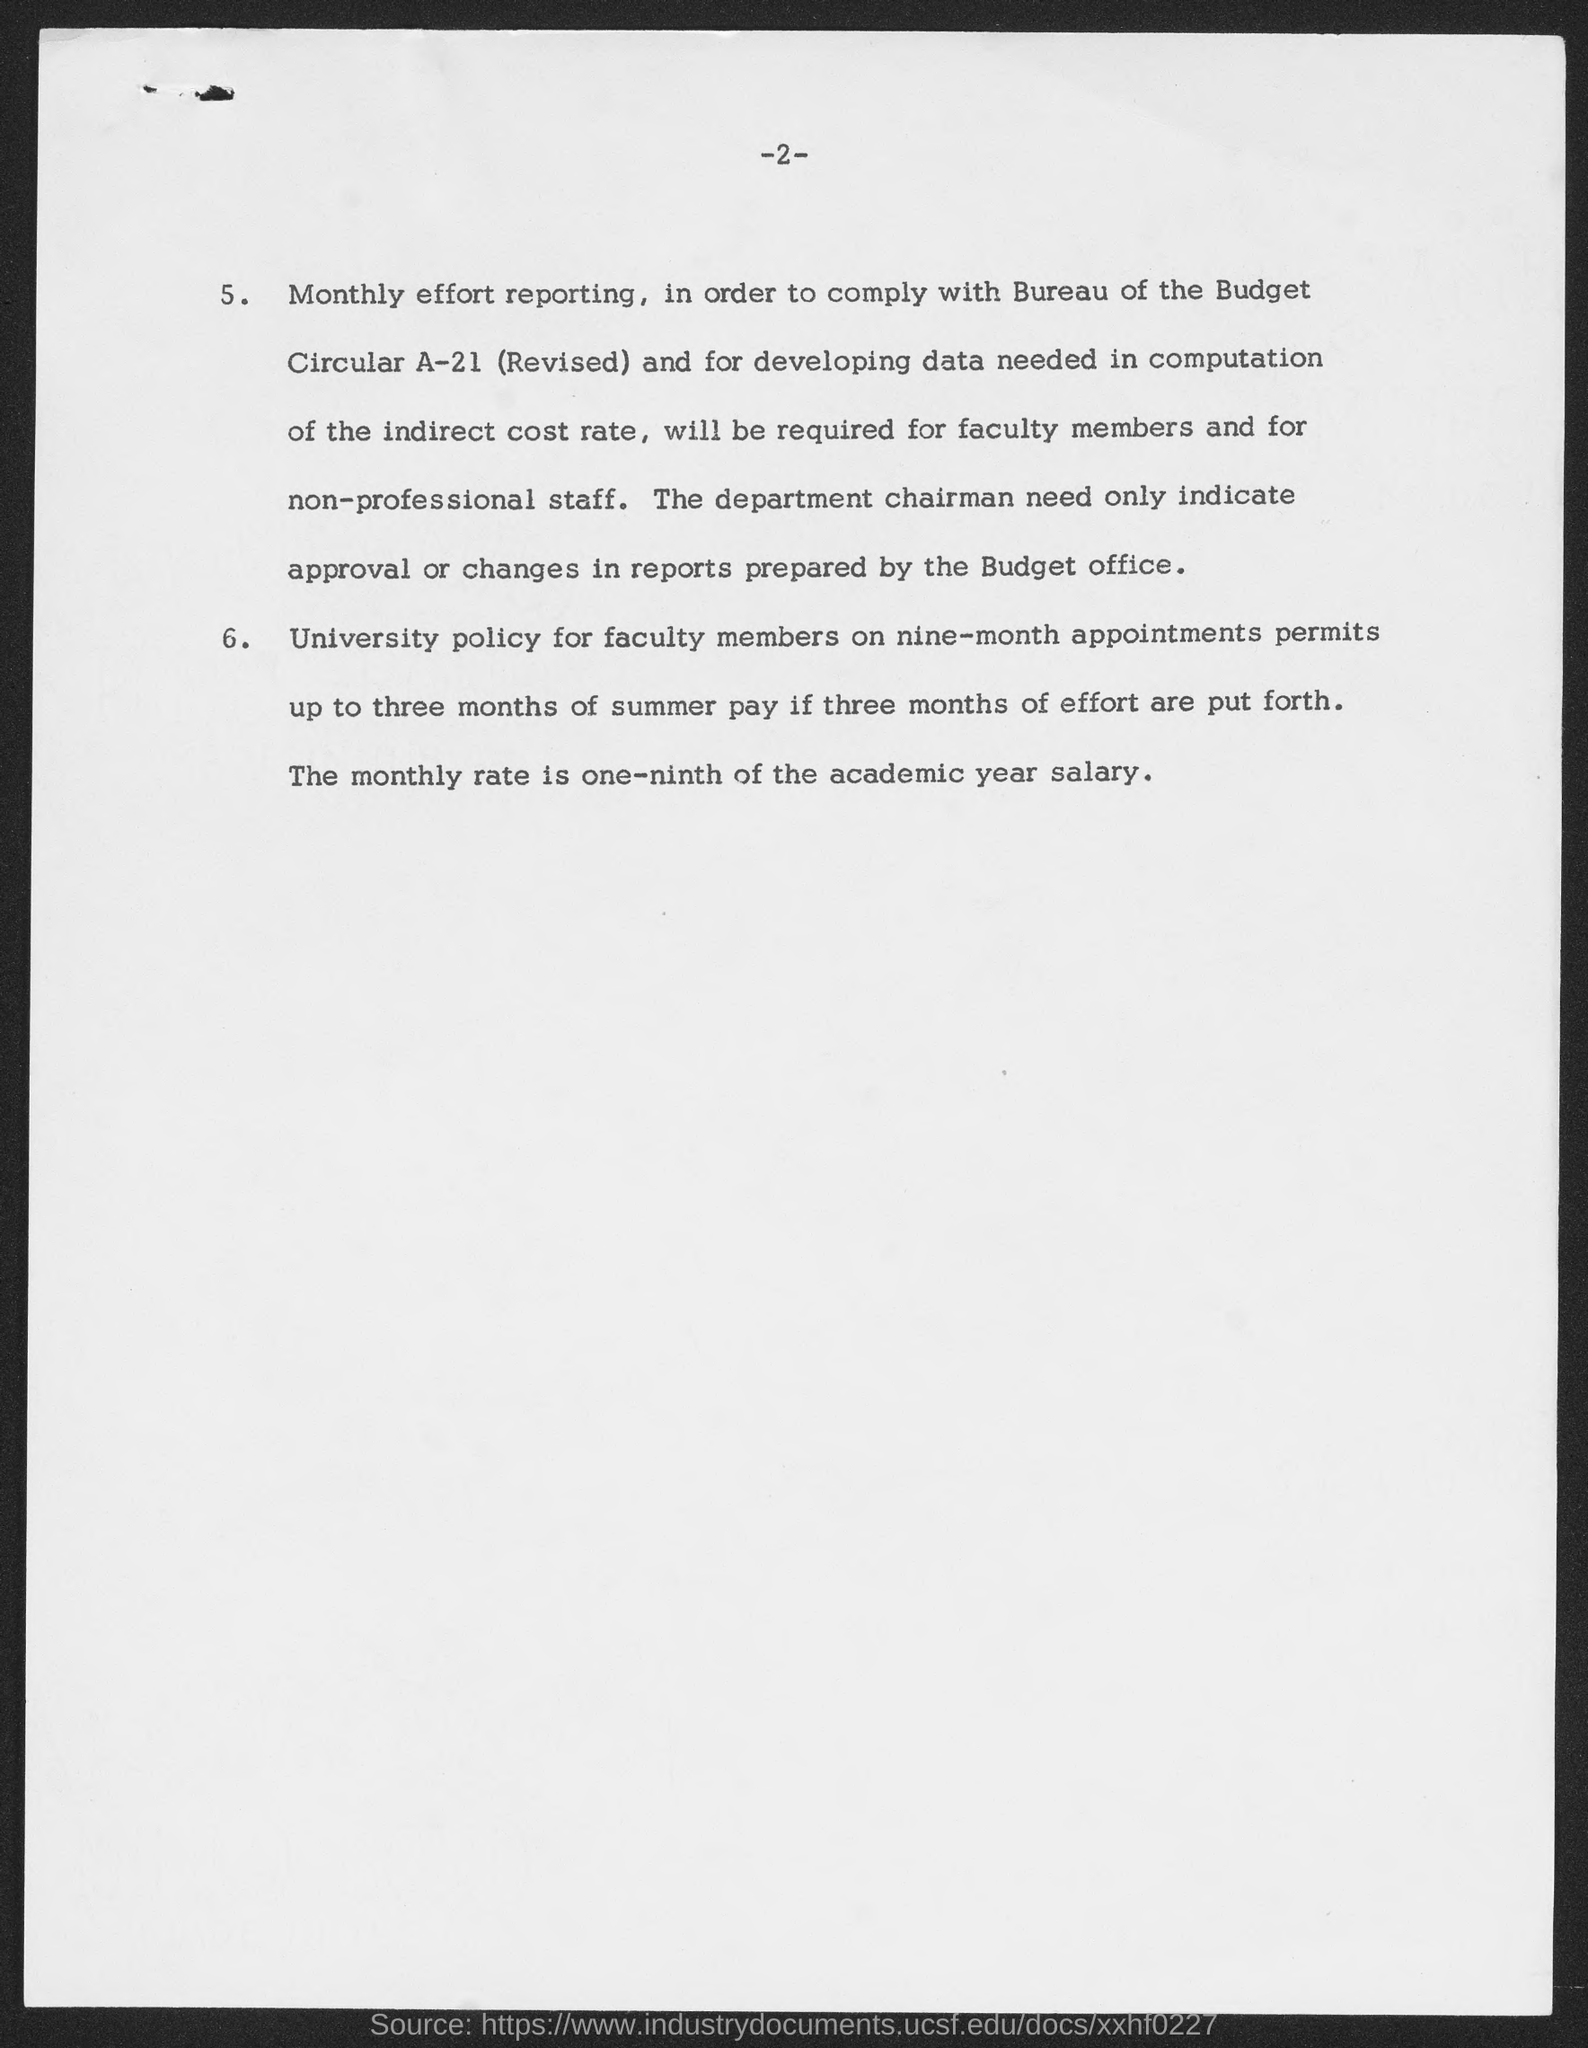What is the page number at top of the page?
Provide a succinct answer. 2. 